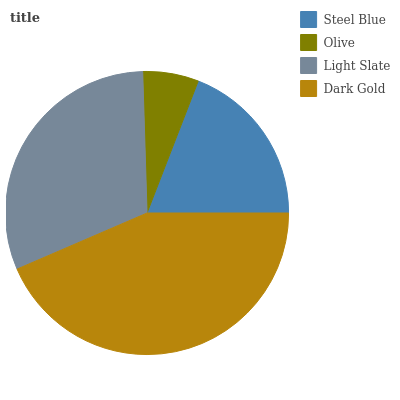Is Olive the minimum?
Answer yes or no. Yes. Is Dark Gold the maximum?
Answer yes or no. Yes. Is Light Slate the minimum?
Answer yes or no. No. Is Light Slate the maximum?
Answer yes or no. No. Is Light Slate greater than Olive?
Answer yes or no. Yes. Is Olive less than Light Slate?
Answer yes or no. Yes. Is Olive greater than Light Slate?
Answer yes or no. No. Is Light Slate less than Olive?
Answer yes or no. No. Is Light Slate the high median?
Answer yes or no. Yes. Is Steel Blue the low median?
Answer yes or no. Yes. Is Dark Gold the high median?
Answer yes or no. No. Is Light Slate the low median?
Answer yes or no. No. 